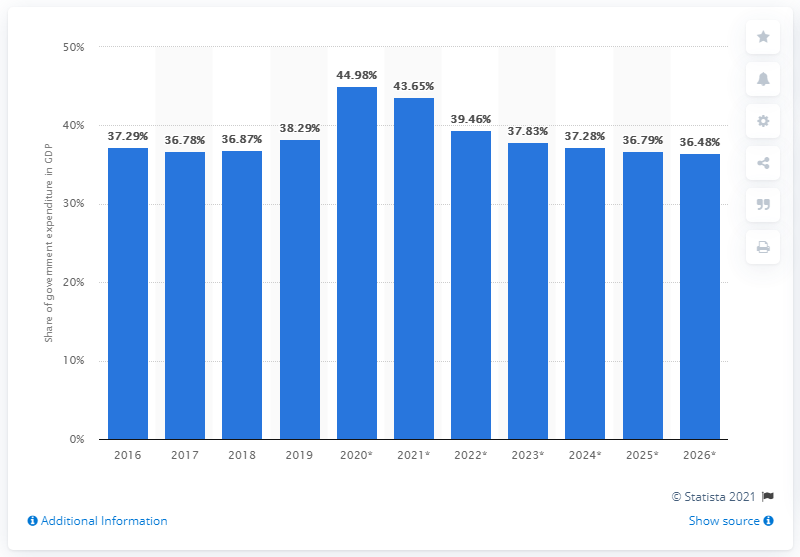List a handful of essential elements in this visual. Australia's national deficit in 2019 represented 38.29% of the country's gross domestic product. 